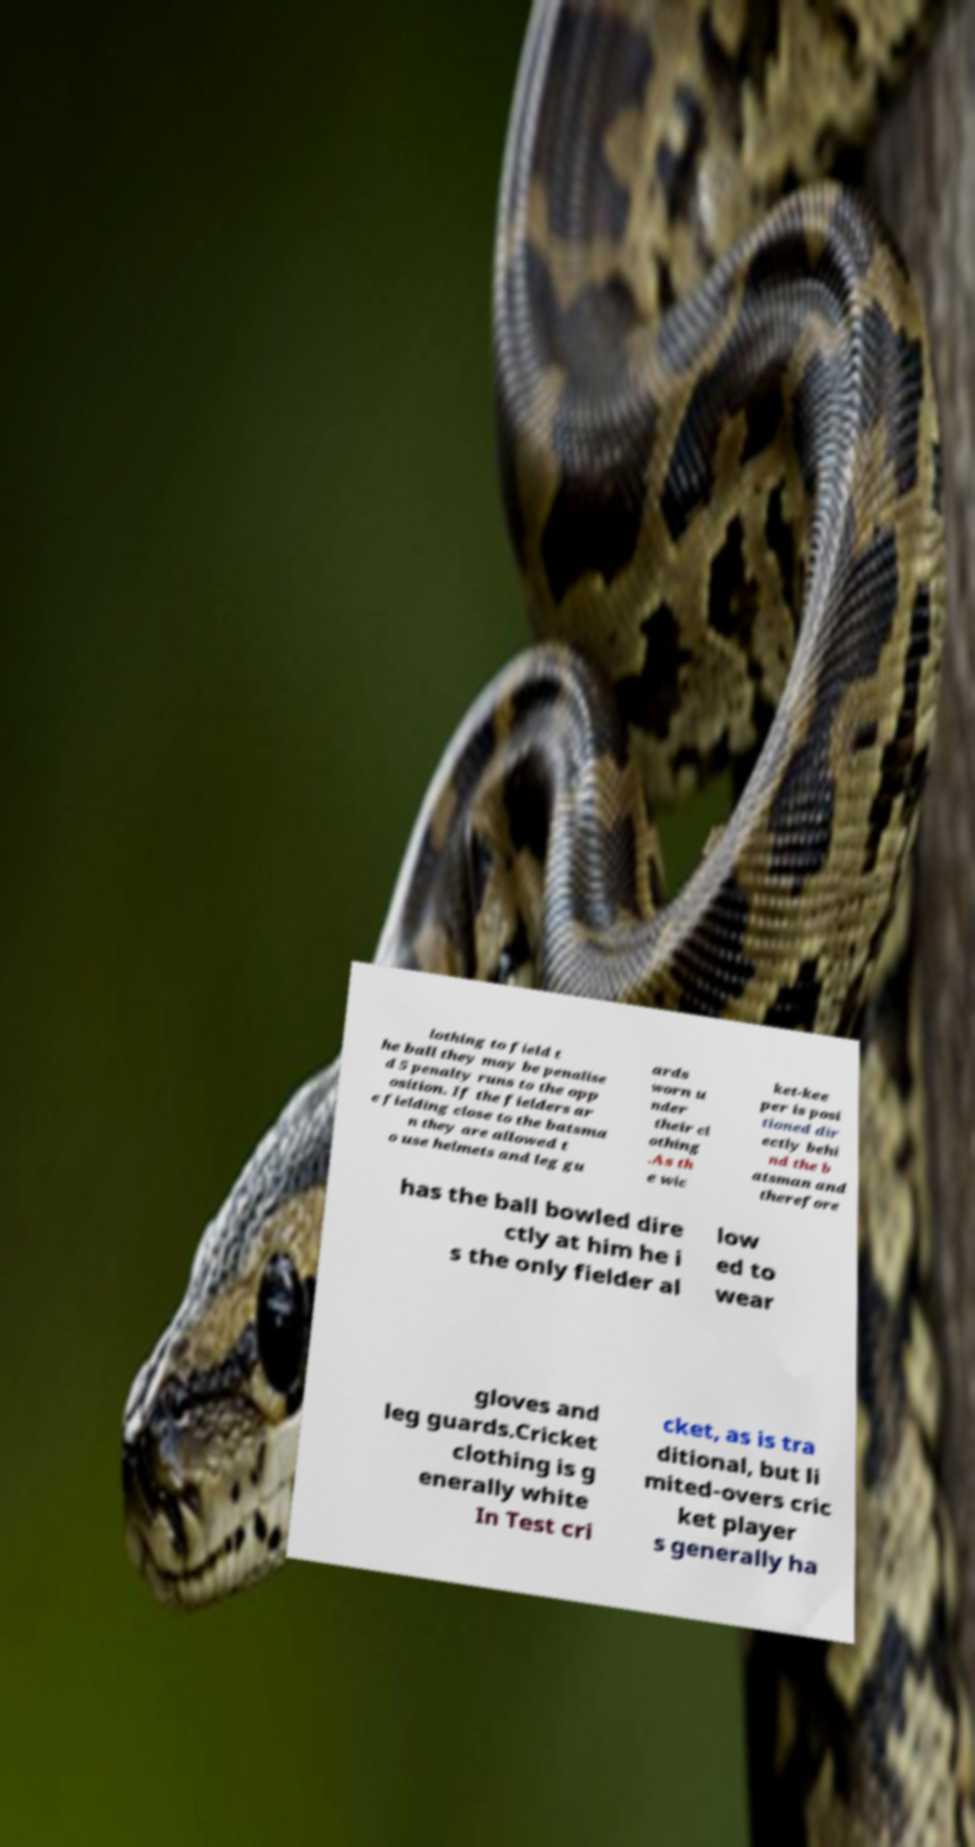For documentation purposes, I need the text within this image transcribed. Could you provide that? lothing to field t he ball they may be penalise d 5 penalty runs to the opp osition. If the fielders ar e fielding close to the batsma n they are allowed t o use helmets and leg gu ards worn u nder their cl othing .As th e wic ket-kee per is posi tioned dir ectly behi nd the b atsman and therefore has the ball bowled dire ctly at him he i s the only fielder al low ed to wear gloves and leg guards.Cricket clothing is g enerally white In Test cri cket, as is tra ditional, but li mited-overs cric ket player s generally ha 